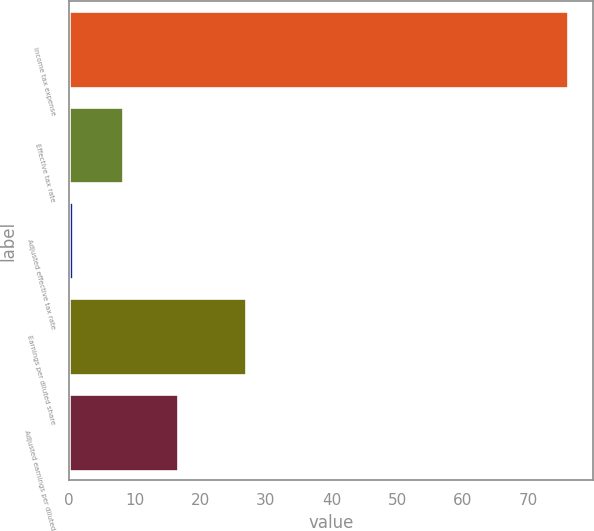<chart> <loc_0><loc_0><loc_500><loc_500><bar_chart><fcel>Income tax expense<fcel>Effective tax rate<fcel>Adjusted effective tax rate<fcel>Earnings per diluted share<fcel>Adjusted earnings per diluted<nl><fcel>76.1<fcel>8.15<fcel>0.6<fcel>26.9<fcel>16.6<nl></chart> 